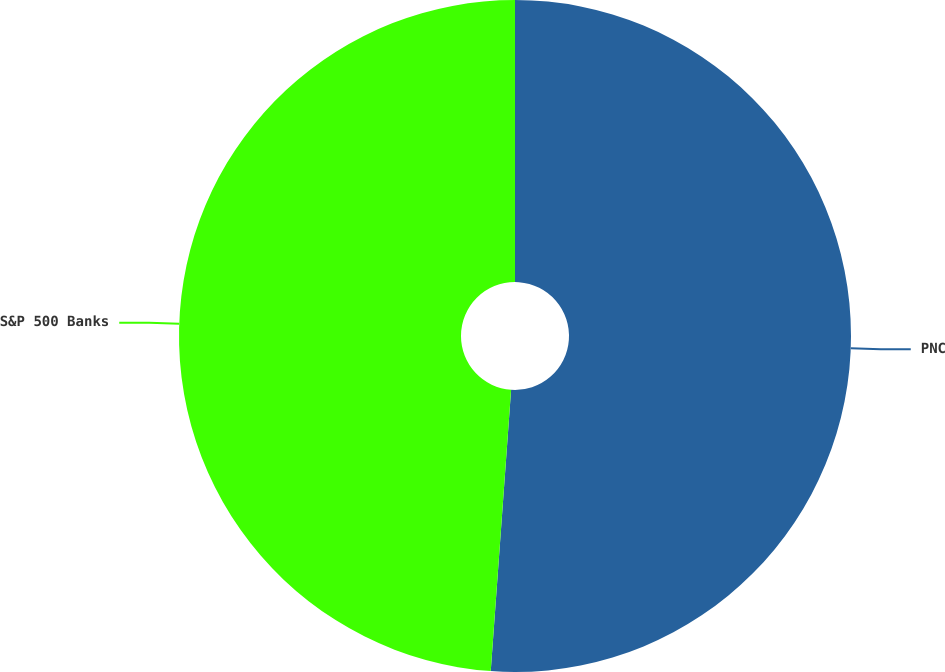Convert chart to OTSL. <chart><loc_0><loc_0><loc_500><loc_500><pie_chart><fcel>PNC<fcel>S&P 500 Banks<nl><fcel>51.15%<fcel>48.85%<nl></chart> 